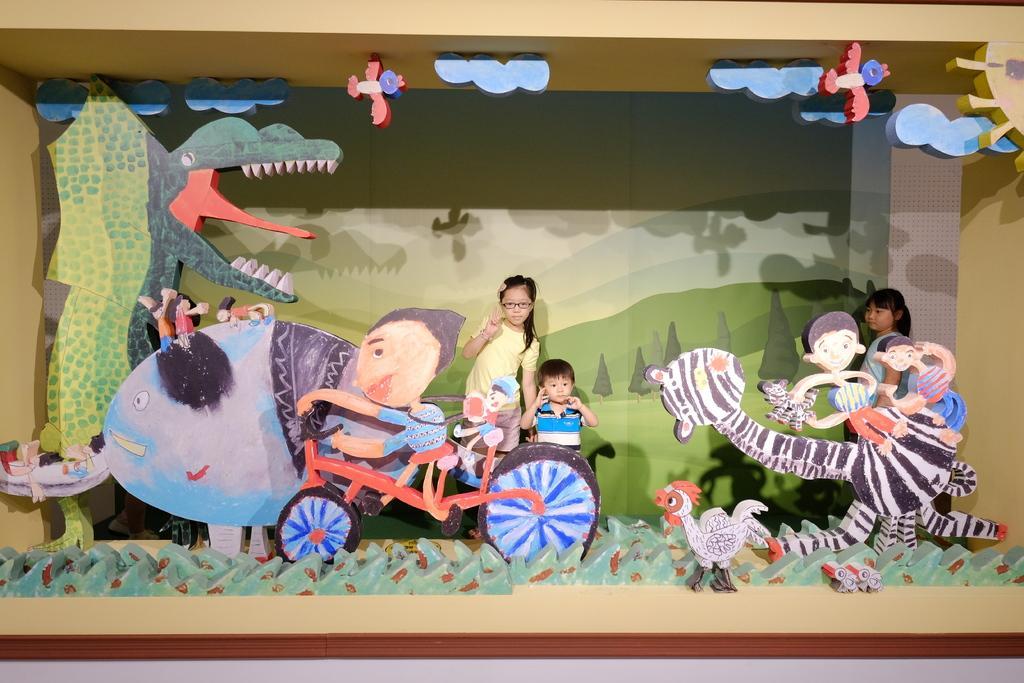Please provide a concise description of this image. In this image we can see there is a depiction of clouds, birds, dragon, fish, bicycle, on the bicycle there is a depiction of a person, hens, grass, giraffe and depiction of persons on it, behind this all there are three children standing in the background there is a banner with painting of trees, mountains and the sky. 